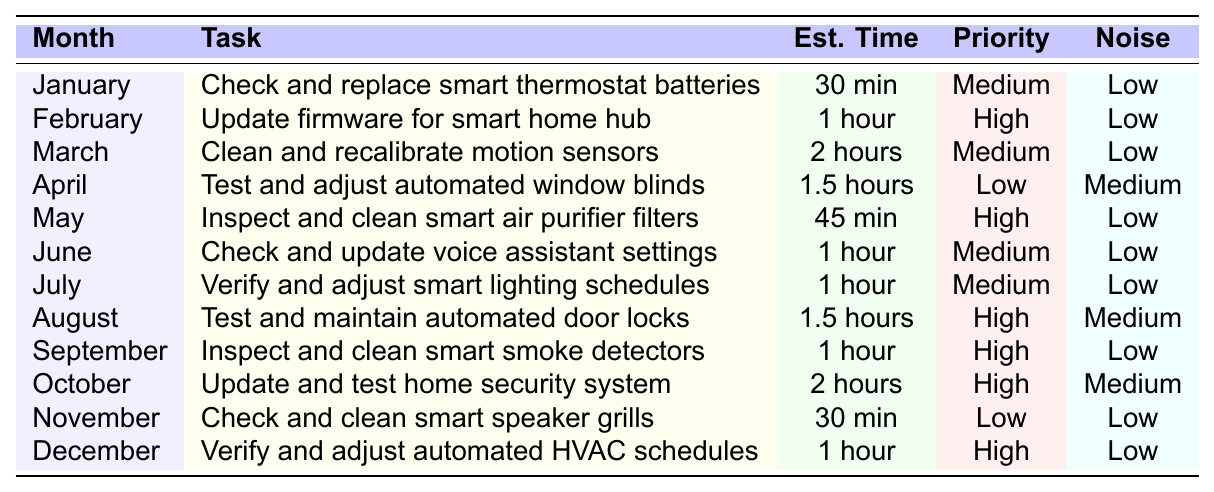What task is scheduled for April? The table indicates that in April, the task is to "Test and adjust automated window blinds."
Answer: Test and adjust automated window blinds Which month has the highest priority task? By inspecting the table, we see that several months list "High" for priority, including February (Update firmware for smart home hub), May (Inspect and clean smart air purifier filters), September (Inspect and clean smart smoke detectors), October (Update and test home security system), and December (Verify and adjust automated HVAC schedules).
Answer: February, May, September, October, December What is the estimated time for cleaning smart smoke detectors? According to the table, the estimated time for the task in September, which involves inspecting and cleaning smart smoke detectors, is 1 hour.
Answer: 1 hour How many tasks are scheduled with a 'low' noise level? Upon reviewing the table, tasks with a low noise level are in January, February, March, May, June, July, September, November, and December. There are a total of 8 tasks with a low noise level.
Answer: 8 What is the total estimated time required for the tasks in August and October? The table states that the task for August ("Test and maintain automated door locks") takes 1.5 hours, while the task for October ("Update and test home security system") takes 2 hours. Adding these gives a total of 3.5 hours.
Answer: 3.5 hours Is there any month that has a task scheduled with a priority marked as 'low'? The table indicates that April (Test and adjust automated window blinds) and November (Check and clean smart speaker grills) both have tasks marked with 'low' priority. Thus, the answer is yes.
Answer: Yes Which month requires the longest time for a task, and what is the task? After examining the table, March requires the longest time (2 hours) for the task of cleaning and calibrating motion sensors.
Answer: March, Cleaning and calibrating motion sensors How many tasks require a high priority and take longer than 1 hour? By reviewing the table, the months with tasks that are both high priority and take longer than 1 hour are August (1.5 hours), September (1 hour), and October (2 hours). Therefore, there are 3 such tasks.
Answer: 3 What is the total estimated time for tasks in the first half of the year? The first half covers January (30 min), February (1 hour), March (2 hours), April (1.5 hours), May (45 min), and June (1 hour). Converting all to hours: 0.5 + 1 + 2 + 1.5 + 0.75 + 1 = 6.75 hours total.
Answer: 6.75 hours 